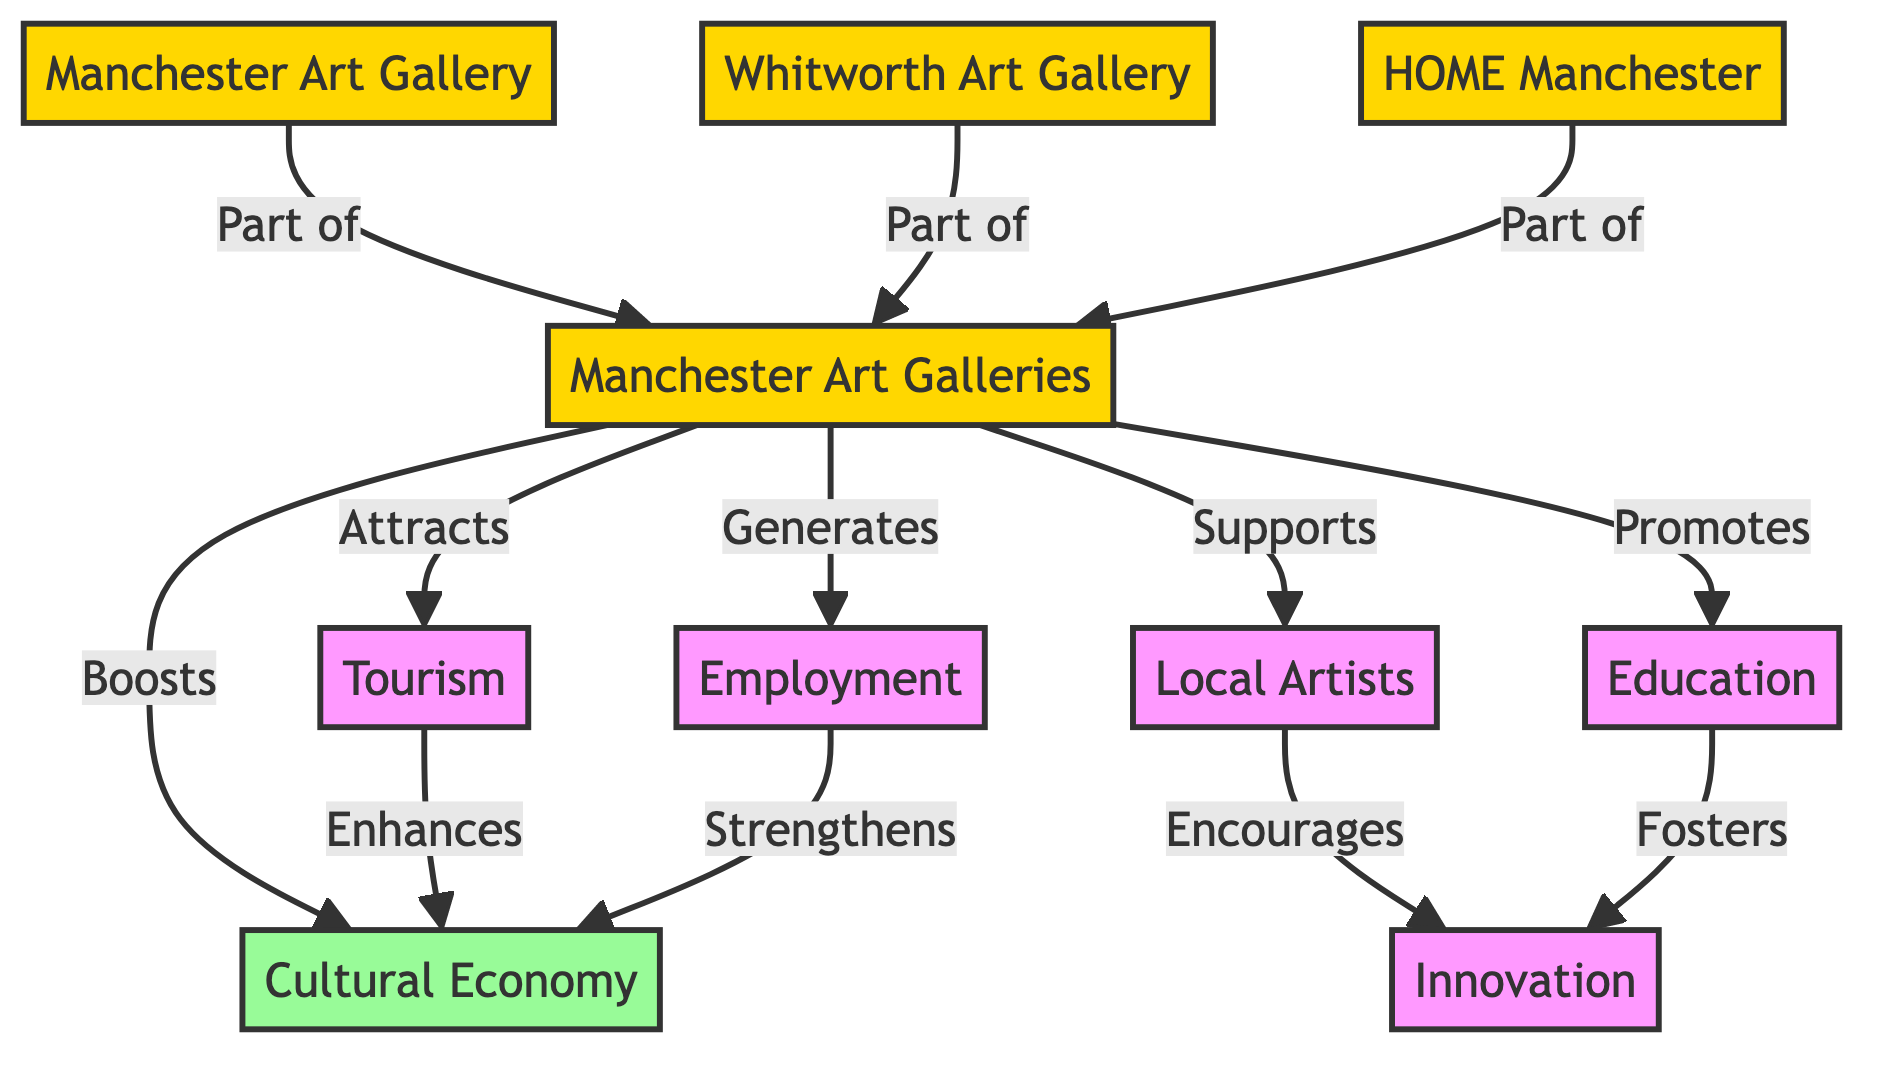What nodes represent the art galleries in Manchester? The art galleries in Manchester represented in the diagram are Manchester Art Gallery, Whitworth Art Gallery, and HOME Manchester. These nodes are specifically identified within the larger node of Manchester Art Galleries.
Answer: Manchester Art Gallery, Whitworth Art Gallery, HOME Manchester How many main categories are there in the diagram? The diagram consists of two main categories, which are identified as Manchester Art Galleries and Cultural Economy. The relationships extending from these nodes also provide further categories, but the main overarching ones are two.
Answer: 2 What relationship does Tourism have with Cultural Economy? The diagram indicates that Tourism enhances Cultural Economy. This relationship is depicted with a directed edge that shows a positive influence between the two nodes.
Answer: Enhances Which part of the diagram supports Local Artists? The Manchester Art Galleries node supports Local Artists, as depicted by a direct connection that indicates the galleries play a role in supporting local creative individuals.
Answer: Supports How does Employment contribute to Cultural Economy? In the diagram, Employment strengthens Cultural Economy, signifying that a robust employment landscape within the cultural sector enhances the overall economic framework.
Answer: Strengthens What is a common effect of both Education and Local Artists? Both Education and Local Artists encourage Innovation, as demonstrated in the diagram where arrows indicate a relationship that both nodes promote innovation within the cultural economy.
Answer: Encourages How many art galleries are part of the Manchester Art Galleries? There are three art galleries that are part of the Manchester Art Galleries: Manchester Art Gallery, Whitworth Art Gallery, and HOME Manchester, as shown within the diagram’s subdivisions.
Answer: 3 What do the Manchester Art Galleries and Local Artists jointly impact? Both Manchester Art Galleries and Local Artists jointly impact Innovation, suggesting that the presence and activity of galleries and artists foster innovative practices and ideas in the cultural economy.
Answer: Innovation What type of diagram is this? This diagram is a Social Science Diagram as it represents the relationships and influences among various elements of Manchester's cultural economy and art galleries.
Answer: Social Science Diagram 